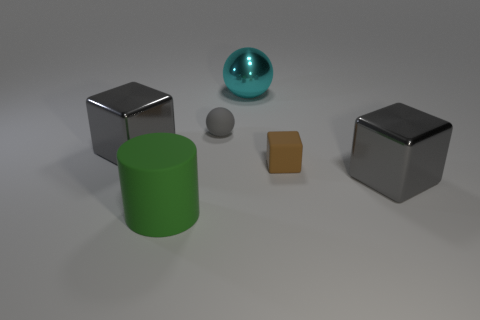How many gray blocks must be subtracted to get 1 gray blocks? 1 Subtract all big cubes. How many cubes are left? 1 Subtract all gray cylinders. How many gray cubes are left? 2 Subtract all brown blocks. How many blocks are left? 2 Subtract 1 blocks. How many blocks are left? 2 Add 3 brown things. How many objects exist? 9 Subtract all cylinders. How many objects are left? 5 Subtract 1 gray balls. How many objects are left? 5 Subtract all yellow balls. Subtract all blue cubes. How many balls are left? 2 Subtract all brown matte objects. Subtract all big metallic balls. How many objects are left? 4 